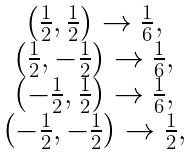Convert formula to latex. <formula><loc_0><loc_0><loc_500><loc_500>\begin{array} [ c ] { c } \left ( \frac { 1 } { 2 } , \frac { 1 } { 2 } \right ) \rightarrow \frac { 1 } { 6 } , \\ \left ( \frac { 1 } { 2 } , - \frac { 1 } { 2 } \right ) \rightarrow \frac { 1 } { 6 } , \\ \left ( - \frac { 1 } { 2 } , \frac { 1 } { 2 } \right ) \rightarrow \frac { 1 } { 6 } , \\ \left ( - \frac { 1 } { 2 } , - \frac { 1 } { 2 } \right ) \rightarrow \frac { 1 } { 2 } , \end{array}</formula> 